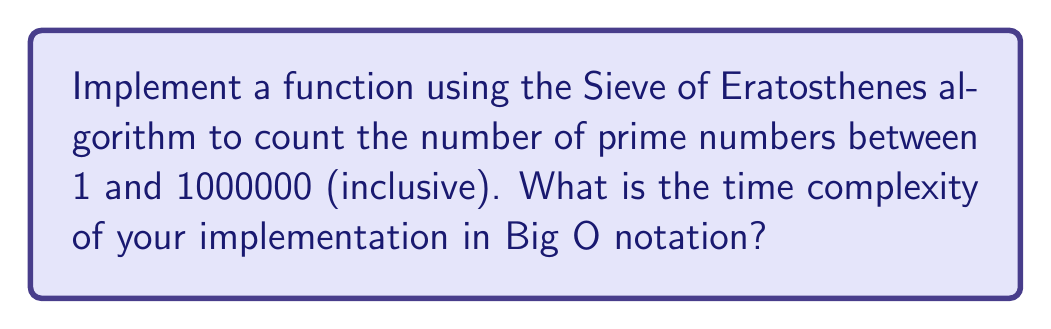Teach me how to tackle this problem. Let's break this down step-by-step:

1. The Sieve of Eratosthenes algorithm for finding prime numbers works as follows:
   a. Create a boolean array of size $n+1$ (where $n$ is the upper limit, 1000000 in this case) initialized to true.
   b. Mark 0 and 1 as non-prime (false).
   c. Iterate from 2 to $\sqrt{n}$:
      - If the current number $i$ is marked prime, mark all its multiples from $i^2$ to $n$ as non-prime.
   d. Count the remaining true values in the array.

2. Implementation in pseudo-code:
   ```
   function countPrimes(n):
       isPrime = [true] * (n+1)
       isPrime[0] = isPrime[1] = false
       count = 0
       for i = 2 to sqrt(n):
           if isPrime[i]:
               for j = i*i to n step i:
                   isPrime[j] = false
       for i = 2 to n:
           if isPrime[i]:
               count++
       return count
   ```

3. Time complexity analysis:
   - The outer loop runs from 2 to $\sqrt{n}$, which is $O(\sqrt{n})$.
   - The inner loop runs approximately $n/i$ times for each $i$.
   - The sum of $n/i$ for $i$ from 2 to $\sqrt{n}$ is approximately $n \log \log n$.
   - The final counting loop is $O(n)$.

4. Therefore, the overall time complexity is $O(n \log \log n + n) = O(n \log \log n)$.

This algorithm is significantly faster than the naive approach of checking each number individually, which would have a time complexity of $O(n\sqrt{n})$.
Answer: $O(n \log \log n)$ 